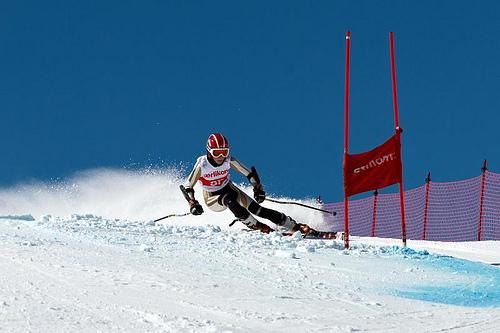Question: why is it cold?
Choices:
A. Winter.
B. Taken in Antarctica.
C. Snowy.
D. On a mountain.
Answer with the letter. Answer: C Question: when was picture taken?
Choices:
A. Winter.
B. Vacation.
C. Ski park.
D. Family reunion.
Answer with the letter. Answer: C Question: what is the player doing?
Choices:
A. Dribbling ball.
B. Sitting on the bench.
C. Skiing.
D. Waiting to bat.
Answer with the letter. Answer: C Question: where is the person?
Choices:
A. On the beach.
B. In snow.
C. In a chair.
D. On the porch.
Answer with the letter. Answer: B Question: who is skiing?
Choices:
A. A young man.
B. A group of friends.
C. A person.
D. An old woman.
Answer with the letter. Answer: C 